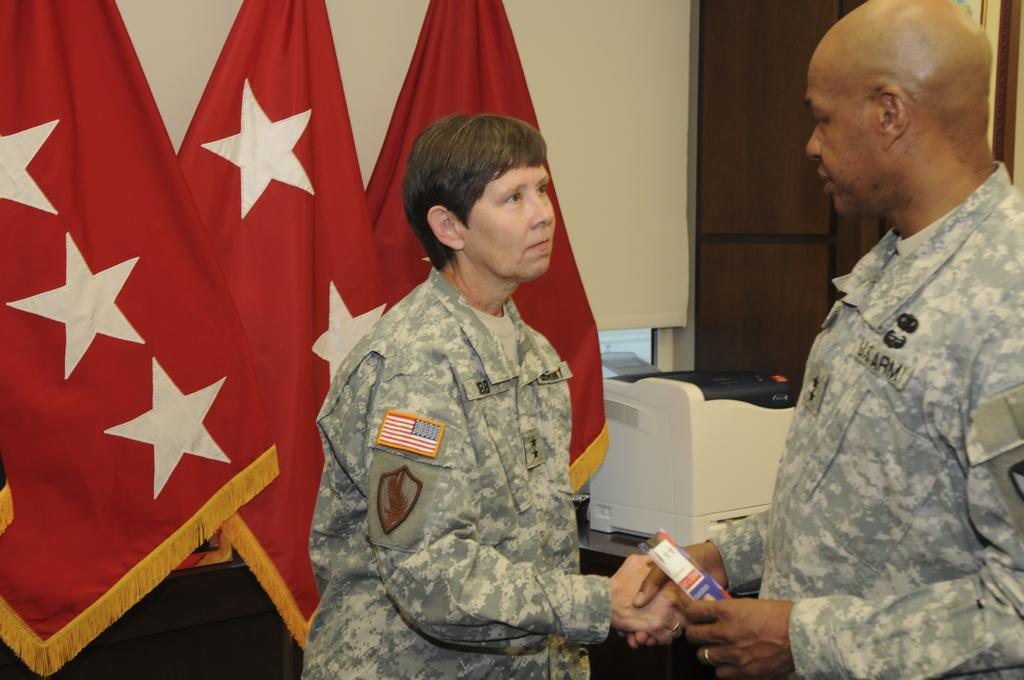What are the two people in the image doing? The two people in the image are standing and shaking hands. Can you describe the object being held by one of the people? One of the people is holding an object, but the specific details of the object are not clear from the image. What can be seen in the background of the image? There are flags and a wall in the background. What type of equipment is visible in the background? There is a printer on a surface in the background. How many frogs are hopping on the printer in the image? There are no frogs visible in the image, and therefore no frogs are hopping on the printer. What is the purpose of the operation being conducted by the people in the image? The purpose of the operation being conducted by the people in the image is not clear from the image itself, as it only shows them shaking hands. 